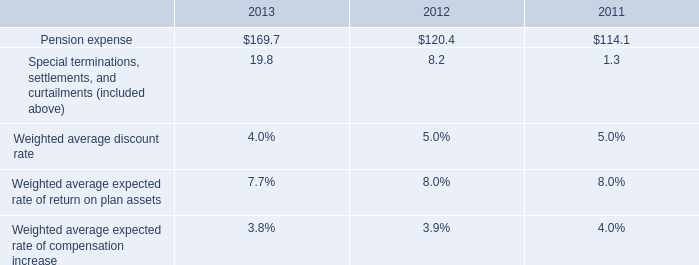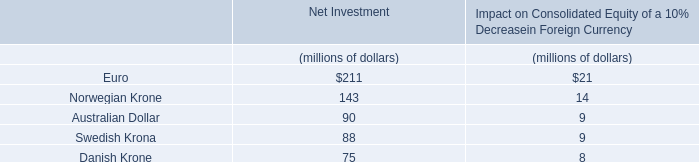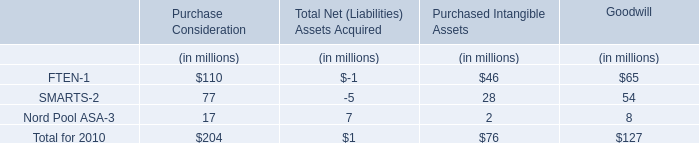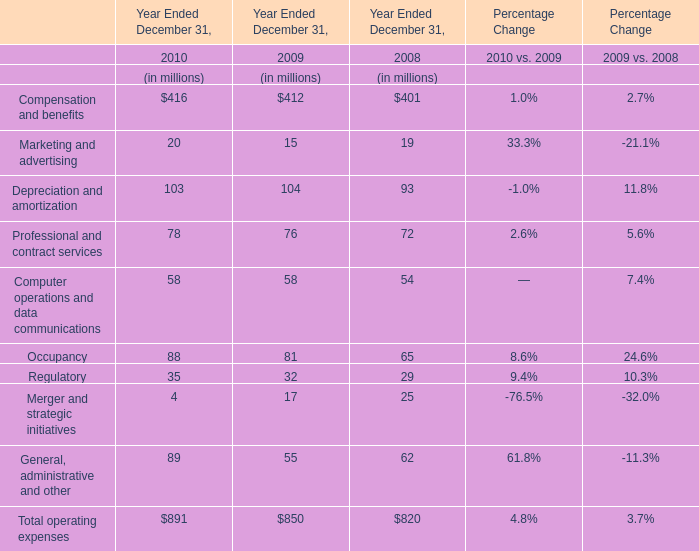What's the average of Professional and contract services and Computer operations and data communications in 2010? (in million) 
Computations: ((78 + 58) / 2)
Answer: 68.0. 